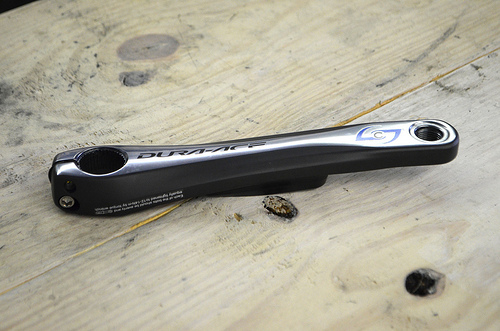<image>
Can you confirm if the tool is to the right of the table? No. The tool is not to the right of the table. The horizontal positioning shows a different relationship. 